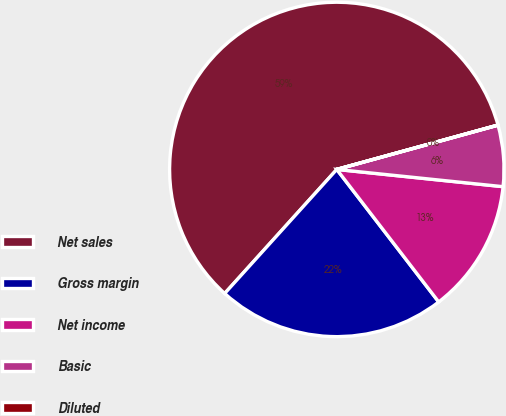<chart> <loc_0><loc_0><loc_500><loc_500><pie_chart><fcel>Net sales<fcel>Gross margin<fcel>Net income<fcel>Basic<fcel>Diluted<nl><fcel>59.02%<fcel>22.13%<fcel>12.92%<fcel>5.91%<fcel>0.01%<nl></chart> 